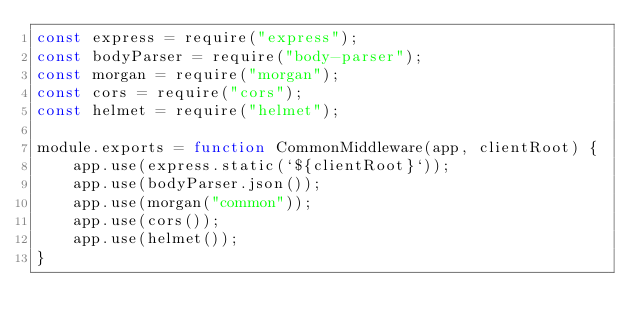<code> <loc_0><loc_0><loc_500><loc_500><_JavaScript_>const express = require("express");
const bodyParser = require("body-parser");
const morgan = require("morgan");
const cors = require("cors");
const helmet = require("helmet");

module.exports = function CommonMiddleware(app, clientRoot) {
    app.use(express.static(`${clientRoot}`));
    app.use(bodyParser.json());
    app.use(morgan("common"));
    app.use(cors());
    app.use(helmet());
}</code> 